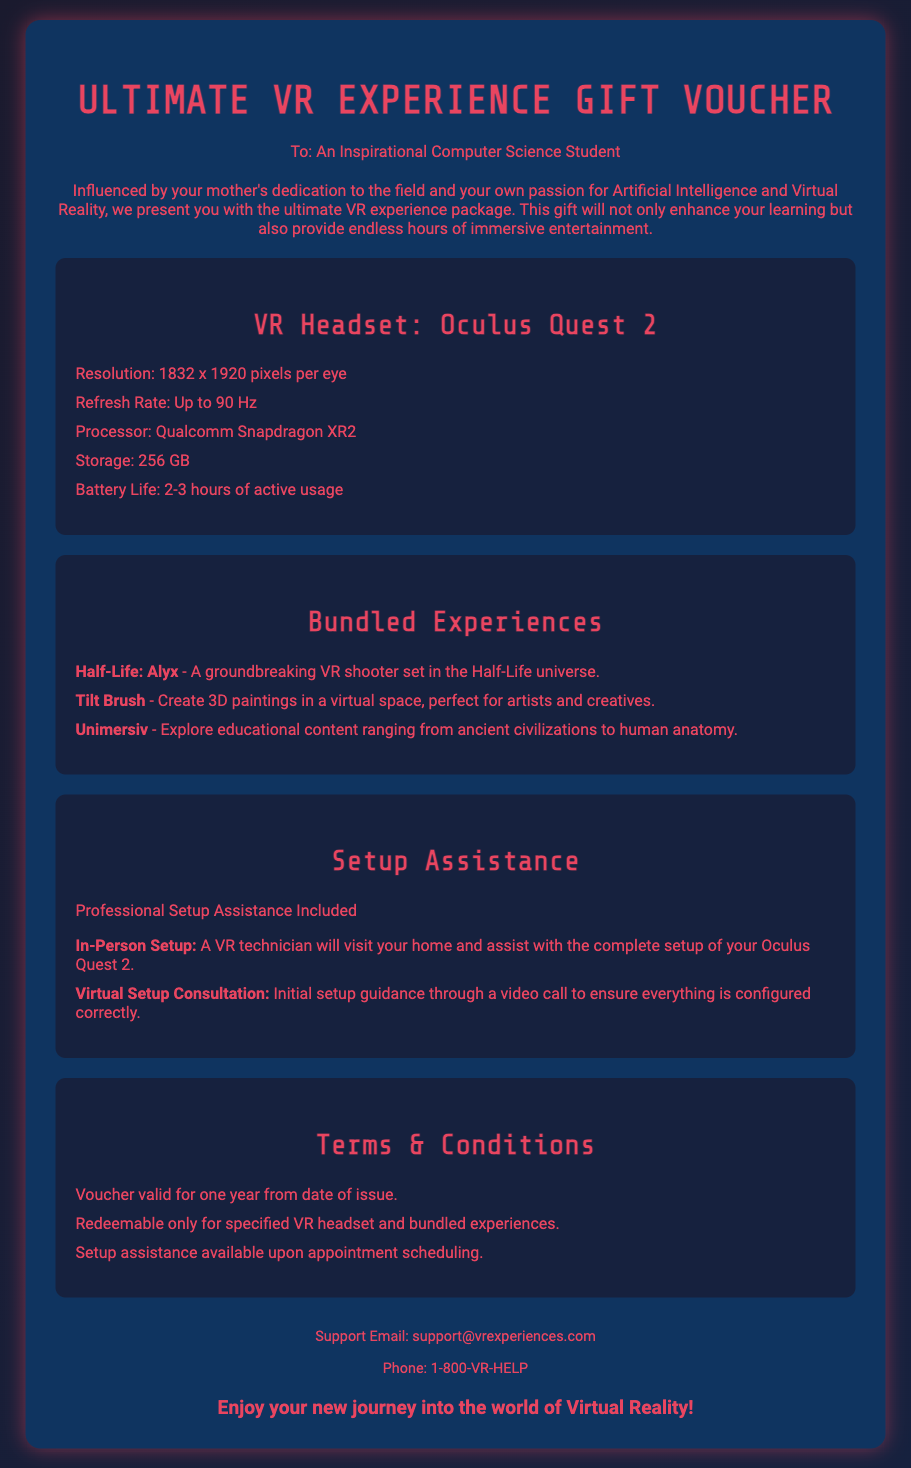What is the name of the VR headset? The name of the VR headset is specified in the product details section of the document.
Answer: Oculus Quest 2 What is the resolution of the Oculus Quest 2? The resolution is listed in the product details section of the document.
Answer: 1832 x 1920 pixels per eye How long is the battery life of the headset? The battery life for the Oculus Quest 2 is provided in the product details section.
Answer: 2-3 hours Which experience allows creating 3D paintings? This experience is mentioned in the bundled experiences section as one for artists and creatives.
Answer: Tilt Brush What type of assistance is included with the gift? The type of assistance is outlined under the setup assistance section, indicating what will be provided.
Answer: Professional Setup Assistance What is the term for redeeming the voucher? The terms concerning the validity of the voucher are included in the terms and conditions section.
Answer: One year What phone number can be contacted for support? The contact information for support specifies a contact number in the document.
Answer: 1-800-VR-HELP How many bundled experiences are included? The bundled experiences section lists the specific experiences provided with the gift.
Answer: Three What educational content can be explored with Unimersiv? This content is mentioned specifically within the bundled experiences section.
Answer: Ancient civilizations to human anatomy 